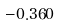<formula> <loc_0><loc_0><loc_500><loc_500>- 0 . 3 6 0</formula> 